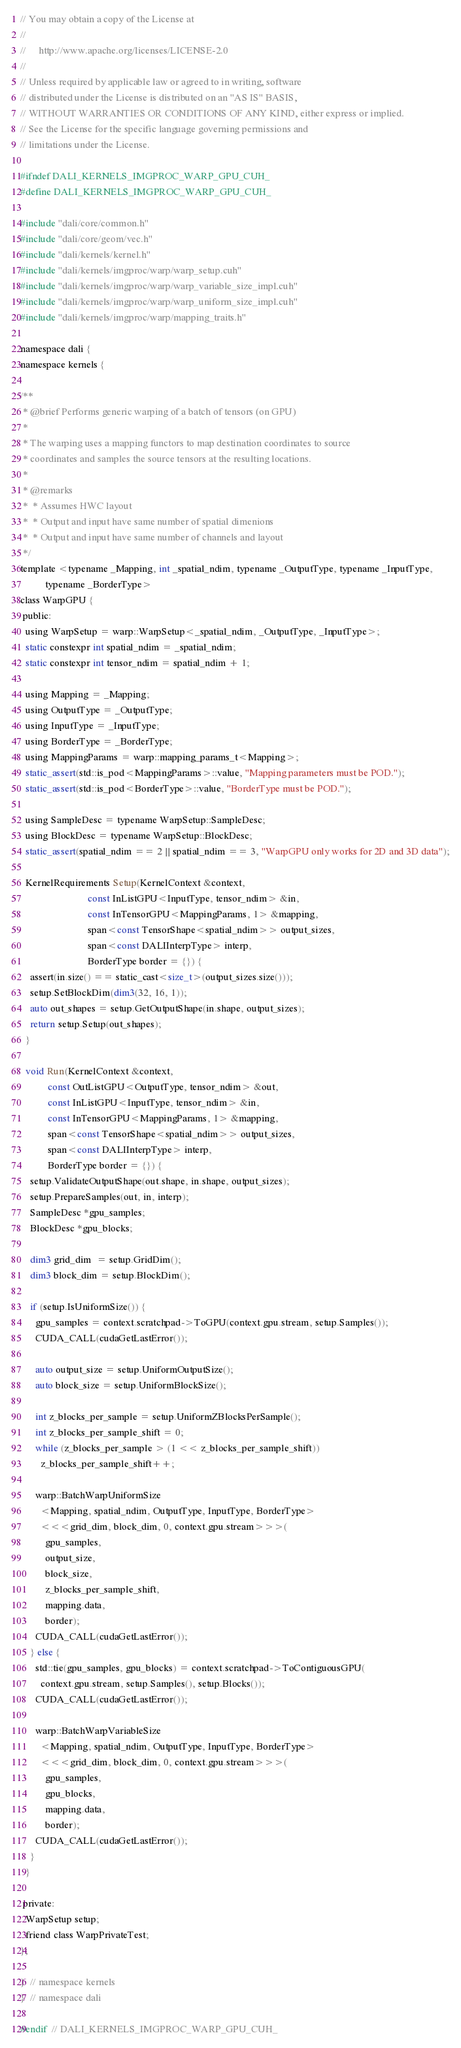<code> <loc_0><loc_0><loc_500><loc_500><_Cuda_>// You may obtain a copy of the License at
//
//     http://www.apache.org/licenses/LICENSE-2.0
//
// Unless required by applicable law or agreed to in writing, software
// distributed under the License is distributed on an "AS IS" BASIS,
// WITHOUT WARRANTIES OR CONDITIONS OF ANY KIND, either express or implied.
// See the License for the specific language governing permissions and
// limitations under the License.

#ifndef DALI_KERNELS_IMGPROC_WARP_GPU_CUH_
#define DALI_KERNELS_IMGPROC_WARP_GPU_CUH_

#include "dali/core/common.h"
#include "dali/core/geom/vec.h"
#include "dali/kernels/kernel.h"
#include "dali/kernels/imgproc/warp/warp_setup.cuh"
#include "dali/kernels/imgproc/warp/warp_variable_size_impl.cuh"
#include "dali/kernels/imgproc/warp/warp_uniform_size_impl.cuh"
#include "dali/kernels/imgproc/warp/mapping_traits.h"

namespace dali {
namespace kernels {

/**
 * @brief Performs generic warping of a batch of tensors (on GPU)
 *
 * The warping uses a mapping functors to map destination coordinates to source
 * coordinates and samples the source tensors at the resulting locations.
 *
 * @remarks
 *  * Assumes HWC layout
 *  * Output and input have same number of spatial dimenions
 *  * Output and input have same number of channels and layout
 */
template <typename _Mapping, int _spatial_ndim, typename _OutputType, typename _InputType,
          typename _BorderType>
class WarpGPU {
 public:
  using WarpSetup = warp::WarpSetup<_spatial_ndim, _OutputType, _InputType>;
  static constexpr int spatial_ndim = _spatial_ndim;
  static constexpr int tensor_ndim = spatial_ndim + 1;

  using Mapping = _Mapping;
  using OutputType = _OutputType;
  using InputType = _InputType;
  using BorderType = _BorderType;
  using MappingParams = warp::mapping_params_t<Mapping>;
  static_assert(std::is_pod<MappingParams>::value, "Mapping parameters must be POD.");
  static_assert(std::is_pod<BorderType>::value, "BorderType must be POD.");

  using SampleDesc = typename WarpSetup::SampleDesc;
  using BlockDesc = typename WarpSetup::BlockDesc;
  static_assert(spatial_ndim == 2 || spatial_ndim == 3, "WarpGPU only works for 2D and 3D data");

  KernelRequirements Setup(KernelContext &context,
                           const InListGPU<InputType, tensor_ndim> &in,
                           const InTensorGPU<MappingParams, 1> &mapping,
                           span<const TensorShape<spatial_ndim>> output_sizes,
                           span<const DALIInterpType> interp,
                           BorderType border = {}) {
    assert(in.size() == static_cast<size_t>(output_sizes.size()));
    setup.SetBlockDim(dim3(32, 16, 1));
    auto out_shapes = setup.GetOutputShape(in.shape, output_sizes);
    return setup.Setup(out_shapes);
  }

  void Run(KernelContext &context,
           const OutListGPU<OutputType, tensor_ndim> &out,
           const InListGPU<InputType, tensor_ndim> &in,
           const InTensorGPU<MappingParams, 1> &mapping,
           span<const TensorShape<spatial_ndim>> output_sizes,
           span<const DALIInterpType> interp,
           BorderType border = {}) {
    setup.ValidateOutputShape(out.shape, in.shape, output_sizes);
    setup.PrepareSamples(out, in, interp);
    SampleDesc *gpu_samples;
    BlockDesc *gpu_blocks;

    dim3 grid_dim  = setup.GridDim();
    dim3 block_dim = setup.BlockDim();

    if (setup.IsUniformSize()) {
      gpu_samples = context.scratchpad->ToGPU(context.gpu.stream, setup.Samples());
      CUDA_CALL(cudaGetLastError());

      auto output_size = setup.UniformOutputSize();
      auto block_size = setup.UniformBlockSize();

      int z_blocks_per_sample = setup.UniformZBlocksPerSample();
      int z_blocks_per_sample_shift = 0;
      while (z_blocks_per_sample > (1 << z_blocks_per_sample_shift))
        z_blocks_per_sample_shift++;

      warp::BatchWarpUniformSize
        <Mapping, spatial_ndim, OutputType, InputType, BorderType>
        <<<grid_dim, block_dim, 0, context.gpu.stream>>>(
          gpu_samples,
          output_size,
          block_size,
          z_blocks_per_sample_shift,
          mapping.data,
          border);
      CUDA_CALL(cudaGetLastError());
    } else {
      std::tie(gpu_samples, gpu_blocks) = context.scratchpad->ToContiguousGPU(
        context.gpu.stream, setup.Samples(), setup.Blocks());
      CUDA_CALL(cudaGetLastError());

      warp::BatchWarpVariableSize
        <Mapping, spatial_ndim, OutputType, InputType, BorderType>
        <<<grid_dim, block_dim, 0, context.gpu.stream>>>(
          gpu_samples,
          gpu_blocks,
          mapping.data,
          border);
      CUDA_CALL(cudaGetLastError());
    }
  }

 private:
  WarpSetup setup;
  friend class WarpPrivateTest;
};

}  // namespace kernels
}  // namespace dali

#endif  // DALI_KERNELS_IMGPROC_WARP_GPU_CUH_
</code> 